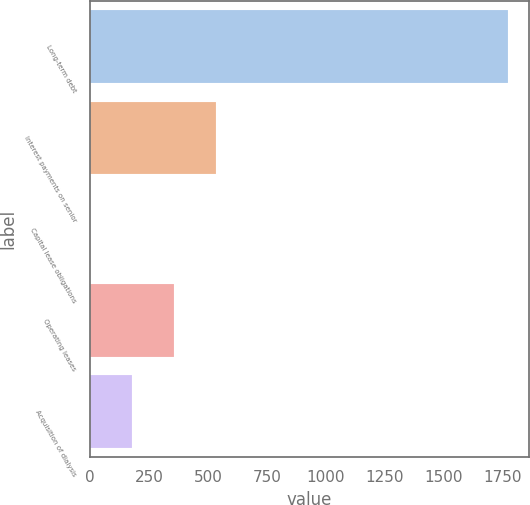Convert chart to OTSL. <chart><loc_0><loc_0><loc_500><loc_500><bar_chart><fcel>Long-term debt<fcel>Interest payments on senior<fcel>Capital lease obligations<fcel>Operating leases<fcel>Acquisition of dialysis<nl><fcel>1772<fcel>532.3<fcel>1<fcel>355.2<fcel>178.1<nl></chart> 